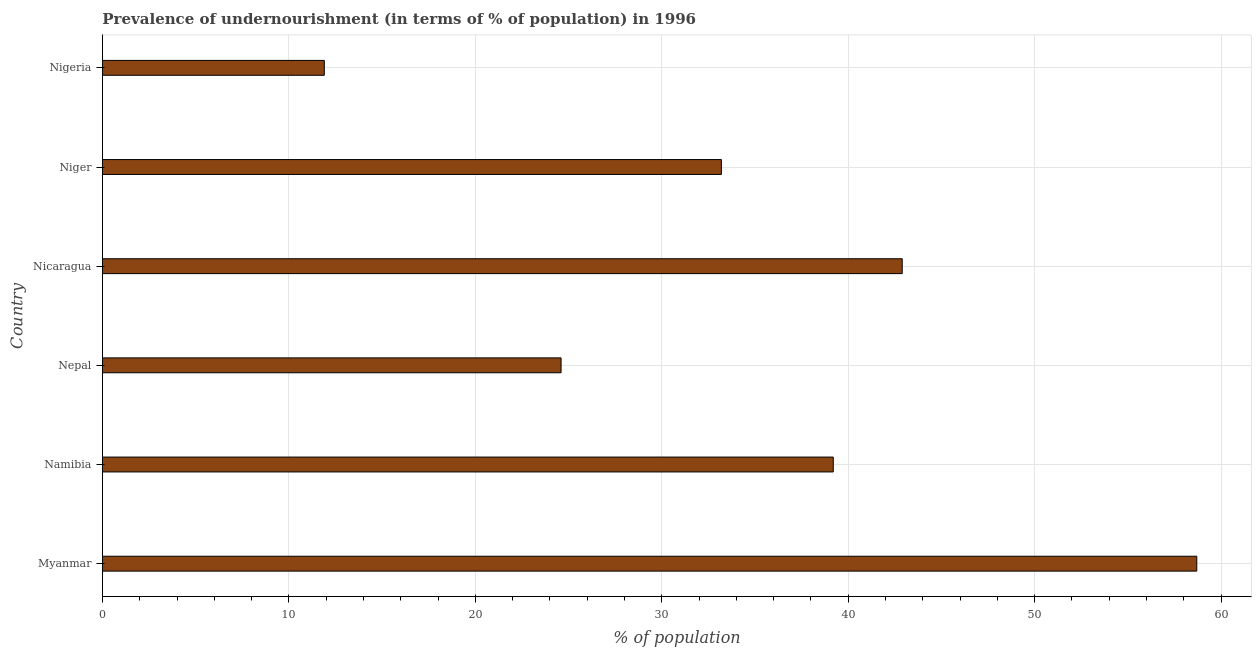Does the graph contain any zero values?
Offer a very short reply. No. Does the graph contain grids?
Provide a succinct answer. Yes. What is the title of the graph?
Your answer should be very brief. Prevalence of undernourishment (in terms of % of population) in 1996. What is the label or title of the X-axis?
Give a very brief answer. % of population. What is the percentage of undernourished population in Nigeria?
Provide a succinct answer. 11.9. Across all countries, what is the maximum percentage of undernourished population?
Your answer should be very brief. 58.7. Across all countries, what is the minimum percentage of undernourished population?
Ensure brevity in your answer.  11.9. In which country was the percentage of undernourished population maximum?
Your answer should be compact. Myanmar. In which country was the percentage of undernourished population minimum?
Offer a very short reply. Nigeria. What is the sum of the percentage of undernourished population?
Provide a succinct answer. 210.5. What is the difference between the percentage of undernourished population in Namibia and Nepal?
Offer a very short reply. 14.6. What is the average percentage of undernourished population per country?
Offer a terse response. 35.08. What is the median percentage of undernourished population?
Keep it short and to the point. 36.2. In how many countries, is the percentage of undernourished population greater than 42 %?
Offer a very short reply. 2. What is the ratio of the percentage of undernourished population in Myanmar to that in Nicaragua?
Provide a short and direct response. 1.37. Is the percentage of undernourished population in Namibia less than that in Nepal?
Offer a very short reply. No. What is the difference between the highest and the second highest percentage of undernourished population?
Offer a terse response. 15.8. What is the difference between the highest and the lowest percentage of undernourished population?
Provide a succinct answer. 46.8. How many countries are there in the graph?
Offer a terse response. 6. Are the values on the major ticks of X-axis written in scientific E-notation?
Give a very brief answer. No. What is the % of population in Myanmar?
Keep it short and to the point. 58.7. What is the % of population of Namibia?
Your answer should be very brief. 39.2. What is the % of population of Nepal?
Ensure brevity in your answer.  24.6. What is the % of population of Nicaragua?
Offer a very short reply. 42.9. What is the % of population of Niger?
Offer a very short reply. 33.2. What is the % of population of Nigeria?
Provide a short and direct response. 11.9. What is the difference between the % of population in Myanmar and Namibia?
Your answer should be very brief. 19.5. What is the difference between the % of population in Myanmar and Nepal?
Your answer should be very brief. 34.1. What is the difference between the % of population in Myanmar and Nigeria?
Provide a short and direct response. 46.8. What is the difference between the % of population in Namibia and Niger?
Offer a terse response. 6. What is the difference between the % of population in Namibia and Nigeria?
Your answer should be very brief. 27.3. What is the difference between the % of population in Nepal and Nicaragua?
Provide a succinct answer. -18.3. What is the difference between the % of population in Nepal and Nigeria?
Keep it short and to the point. 12.7. What is the difference between the % of population in Nicaragua and Niger?
Give a very brief answer. 9.7. What is the difference between the % of population in Niger and Nigeria?
Your answer should be very brief. 21.3. What is the ratio of the % of population in Myanmar to that in Namibia?
Your response must be concise. 1.5. What is the ratio of the % of population in Myanmar to that in Nepal?
Offer a very short reply. 2.39. What is the ratio of the % of population in Myanmar to that in Nicaragua?
Provide a short and direct response. 1.37. What is the ratio of the % of population in Myanmar to that in Niger?
Provide a short and direct response. 1.77. What is the ratio of the % of population in Myanmar to that in Nigeria?
Keep it short and to the point. 4.93. What is the ratio of the % of population in Namibia to that in Nepal?
Give a very brief answer. 1.59. What is the ratio of the % of population in Namibia to that in Nicaragua?
Offer a terse response. 0.91. What is the ratio of the % of population in Namibia to that in Niger?
Keep it short and to the point. 1.18. What is the ratio of the % of population in Namibia to that in Nigeria?
Offer a very short reply. 3.29. What is the ratio of the % of population in Nepal to that in Nicaragua?
Your answer should be compact. 0.57. What is the ratio of the % of population in Nepal to that in Niger?
Provide a short and direct response. 0.74. What is the ratio of the % of population in Nepal to that in Nigeria?
Keep it short and to the point. 2.07. What is the ratio of the % of population in Nicaragua to that in Niger?
Offer a very short reply. 1.29. What is the ratio of the % of population in Nicaragua to that in Nigeria?
Provide a succinct answer. 3.6. What is the ratio of the % of population in Niger to that in Nigeria?
Make the answer very short. 2.79. 